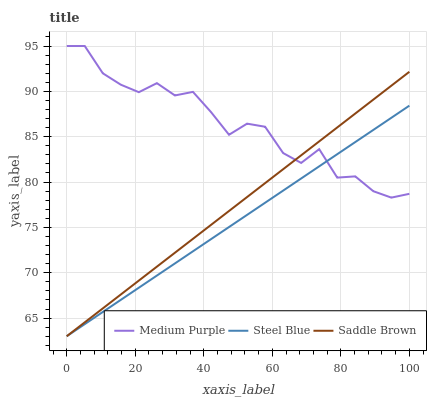Does Steel Blue have the minimum area under the curve?
Answer yes or no. Yes. Does Medium Purple have the maximum area under the curve?
Answer yes or no. Yes. Does Saddle Brown have the minimum area under the curve?
Answer yes or no. No. Does Saddle Brown have the maximum area under the curve?
Answer yes or no. No. Is Saddle Brown the smoothest?
Answer yes or no. Yes. Is Medium Purple the roughest?
Answer yes or no. Yes. Is Steel Blue the smoothest?
Answer yes or no. No. Is Steel Blue the roughest?
Answer yes or no. No. Does Steel Blue have the lowest value?
Answer yes or no. Yes. Does Medium Purple have the highest value?
Answer yes or no. Yes. Does Saddle Brown have the highest value?
Answer yes or no. No. Does Saddle Brown intersect Steel Blue?
Answer yes or no. Yes. Is Saddle Brown less than Steel Blue?
Answer yes or no. No. Is Saddle Brown greater than Steel Blue?
Answer yes or no. No. 